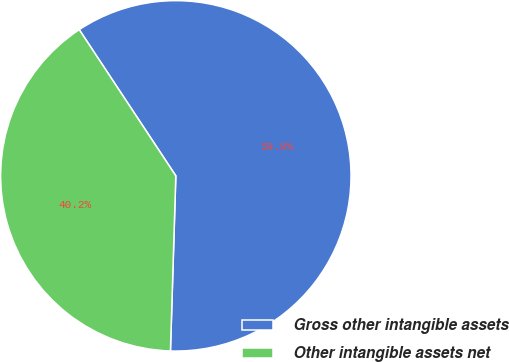Convert chart to OTSL. <chart><loc_0><loc_0><loc_500><loc_500><pie_chart><fcel>Gross other intangible assets<fcel>Other intangible assets net<nl><fcel>59.78%<fcel>40.22%<nl></chart> 